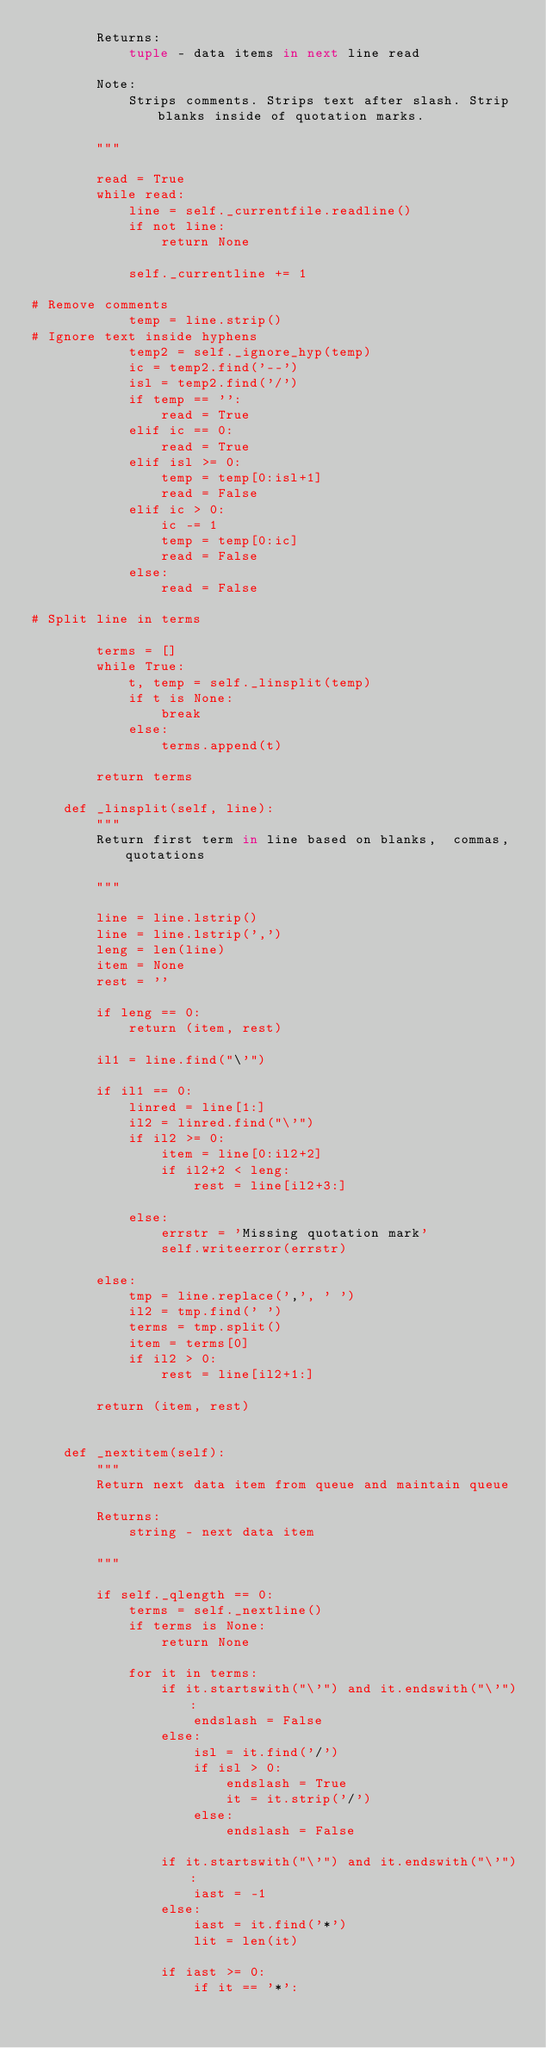Convert code to text. <code><loc_0><loc_0><loc_500><loc_500><_Python_>        Returns:
            tuple - data items in next line read

        Note:
            Strips comments. Strips text after slash. Strip blanks inside of quotation marks.

        """

        read = True
        while read:
            line = self._currentfile.readline()
            if not line:
                return None

            self._currentline += 1

# Remove comments
            temp = line.strip()
# Ignore text inside hyphens
            temp2 = self._ignore_hyp(temp)
            ic = temp2.find('--')
            isl = temp2.find('/')
            if temp == '':
                read = True
            elif ic == 0:
                read = True
            elif isl >= 0:
                temp = temp[0:isl+1]
                read = False
            elif ic > 0:
                ic -= 1
                temp = temp[0:ic]
                read = False
            else:
                read = False

# Split line in terms

        terms = []
        while True:
            t, temp = self._linsplit(temp)
            if t is None:
                break
            else:
                terms.append(t)

        return terms

    def _linsplit(self, line):
        """
        Return first term in line based on blanks,  commas, quotations

        """

        line = line.lstrip()
        line = line.lstrip(',')
        leng = len(line)
        item = None
        rest = ''

        if leng == 0:
            return (item, rest)

        il1 = line.find("\'")

        if il1 == 0:
            linred = line[1:]
            il2 = linred.find("\'")
            if il2 >= 0:
                item = line[0:il2+2]
                if il2+2 < leng:
                    rest = line[il2+3:]

            else:
                errstr = 'Missing quotation mark'
                self.writeerror(errstr)

        else:
            tmp = line.replace(',', ' ')
            il2 = tmp.find(' ')
            terms = tmp.split()
            item = terms[0]
            if il2 > 0:
                rest = line[il2+1:]

        return (item, rest)


    def _nextitem(self):
        """
        Return next data item from queue and maintain queue

        Returns:
            string - next data item

        """

        if self._qlength == 0:
            terms = self._nextline()
            if terms is None:
                return None

            for it in terms:
                if it.startswith("\'") and it.endswith("\'"):
                    endslash = False
                else:
                    isl = it.find('/')
                    if isl > 0:
                        endslash = True
                        it = it.strip('/')
                    else:
                        endslash = False

                if it.startswith("\'") and it.endswith("\'"):
                    iast = -1
                else:
                    iast = it.find('*')
                    lit = len(it)

                if iast >= 0:
                    if it == '*':</code> 